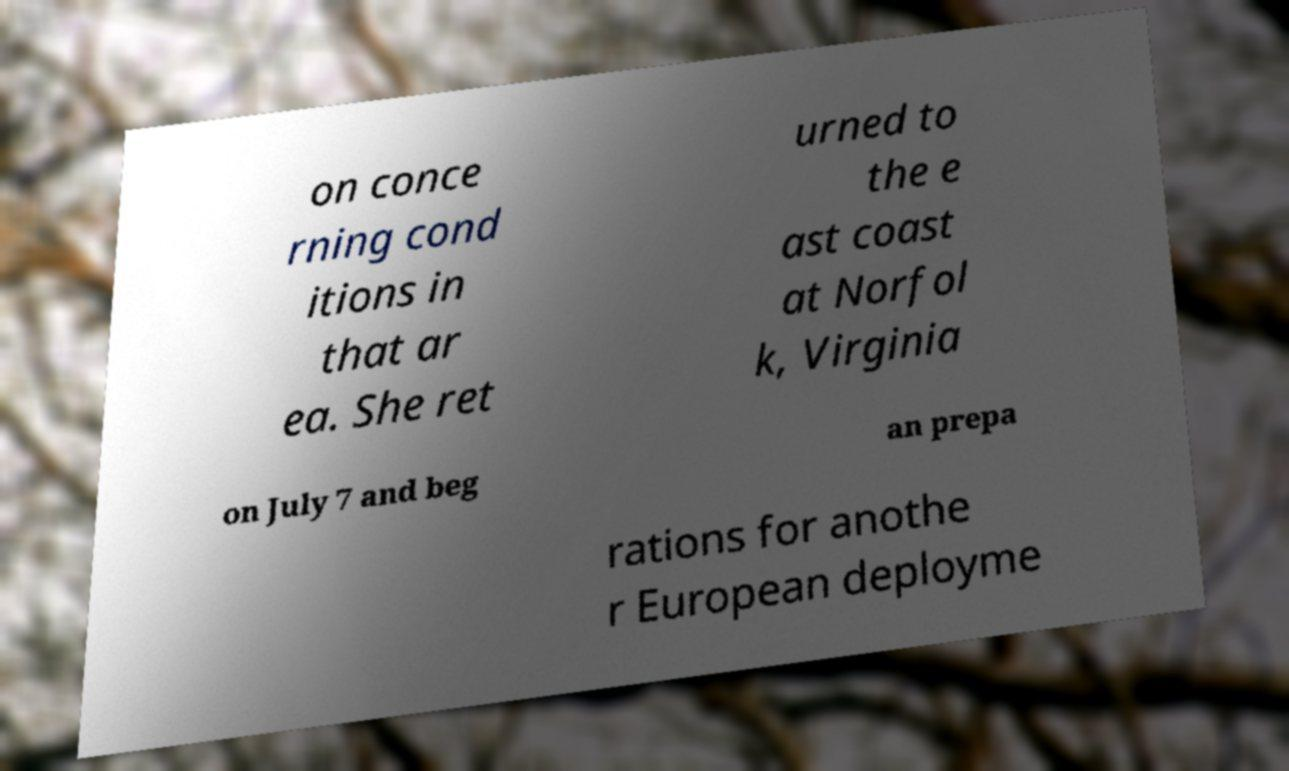I need the written content from this picture converted into text. Can you do that? on conce rning cond itions in that ar ea. She ret urned to the e ast coast at Norfol k, Virginia on July 7 and beg an prepa rations for anothe r European deployme 